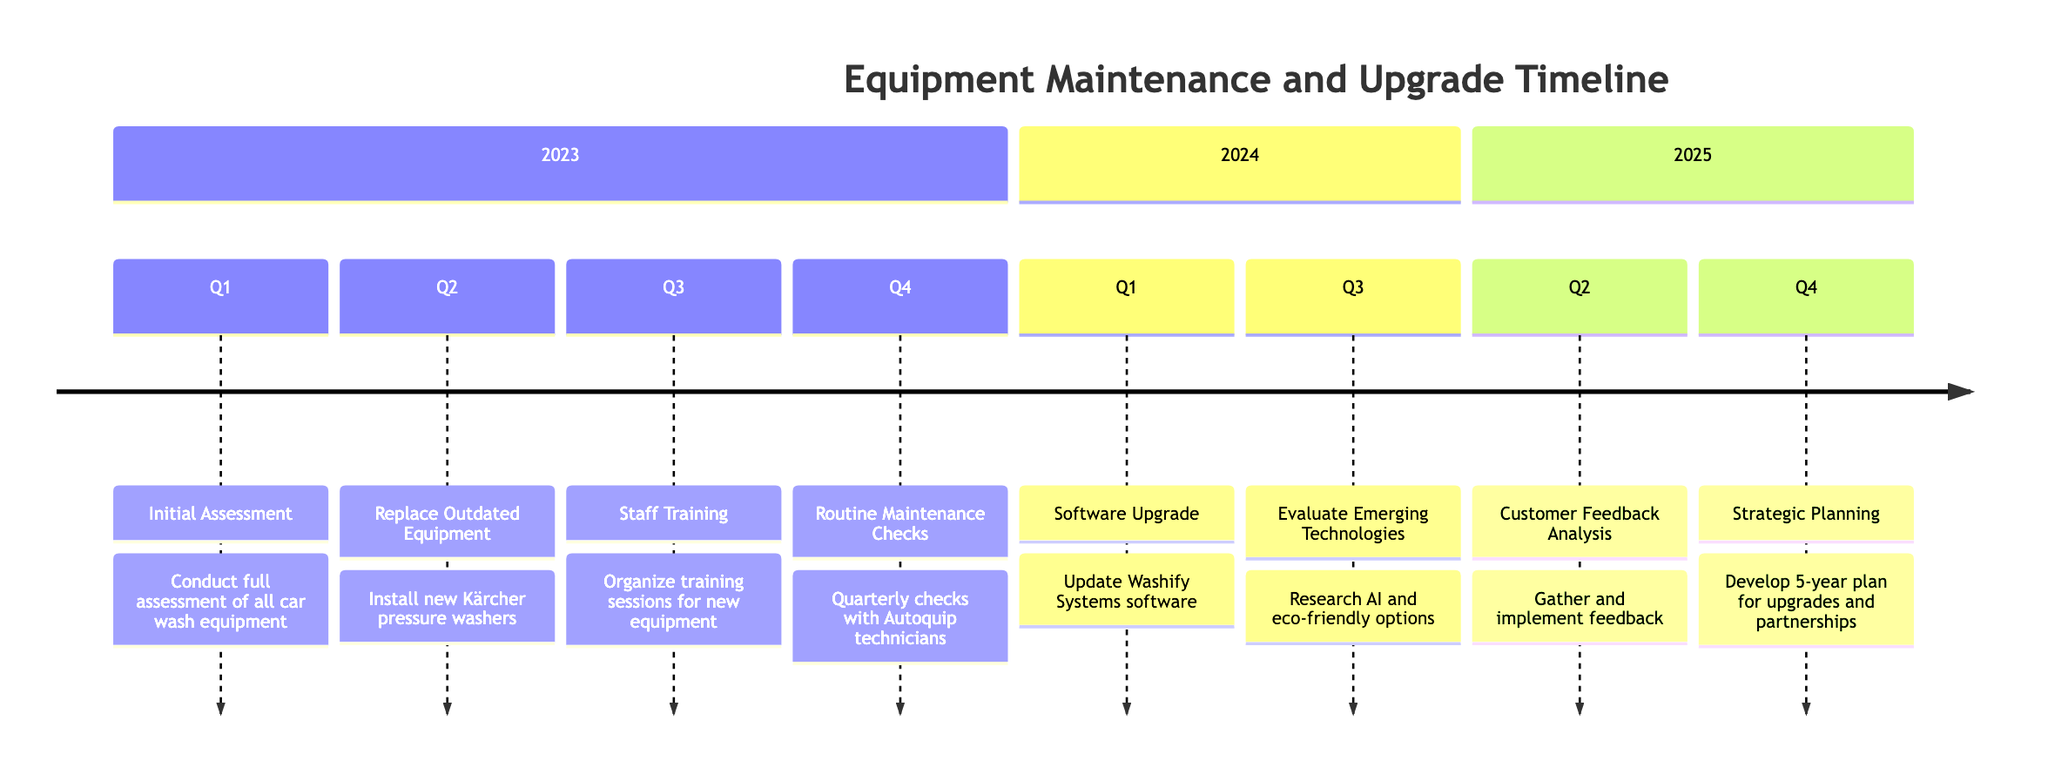What is the first activity listed in 2023? The timeline begins with the activity listed under Q1 of 2023, which is the "Initial Assessment." This is the first entry when reading from the top of the timeline.
Answer: Initial Assessment How many activities are scheduled for Q3 of 2023? According to the timeline, there is one activity listed for Q3 of 2023, which is "Staff Training." There are no other activities in that quarter.
Answer: 1 What will be upgraded in Q1 of 2024? The timeline specifies that in Q1 of 2024, there will be a "Software Upgrade." This is the only activity mentioned for that quarter.
Answer: Software Upgrade During which quarter in 2025 is the Customer Feedback Analysis planned? The timeline marks Q2 of 2025 for the "Customer Feedback Analysis." This is specifically indicated in the 2025 section of the timeline.
Answer: Q2 What are the two main activities planned for 2024? The timeline indicates two activities in 2024: "Software Upgrade" in Q1 and "Evaluate Emerging Technologies" in Q3. These are the only two activities scheduled for that entire year.
Answer: Software Upgrade, Evaluate Emerging Technologies What quarter has the activity for Strategic Planning? The timeline shows that the "Strategic Planning" activity is scheduled for Q4 of 2025. This is towards the end of the timeline.
Answer: Q4 Which activity involves training staff? The "Staff Training" activity is listed under Q3 of 2023. According to the timeline, this is specifically focused on training staff for new equipment.
Answer: Staff Training How many total activities are planned for the year 2025? There are two activities scheduled for 2025: "Customer Feedback Analysis" in Q2 and "Strategic Planning" in Q4. So the total is two.
Answer: 2 What does the activity in Q3 of 2024 focus on? The activity scheduled for Q3 of 2024 is focused on "Evaluate Emerging Technologies." According to the timeline, this activity involves researching new technologies.
Answer: Evaluate Emerging Technologies 